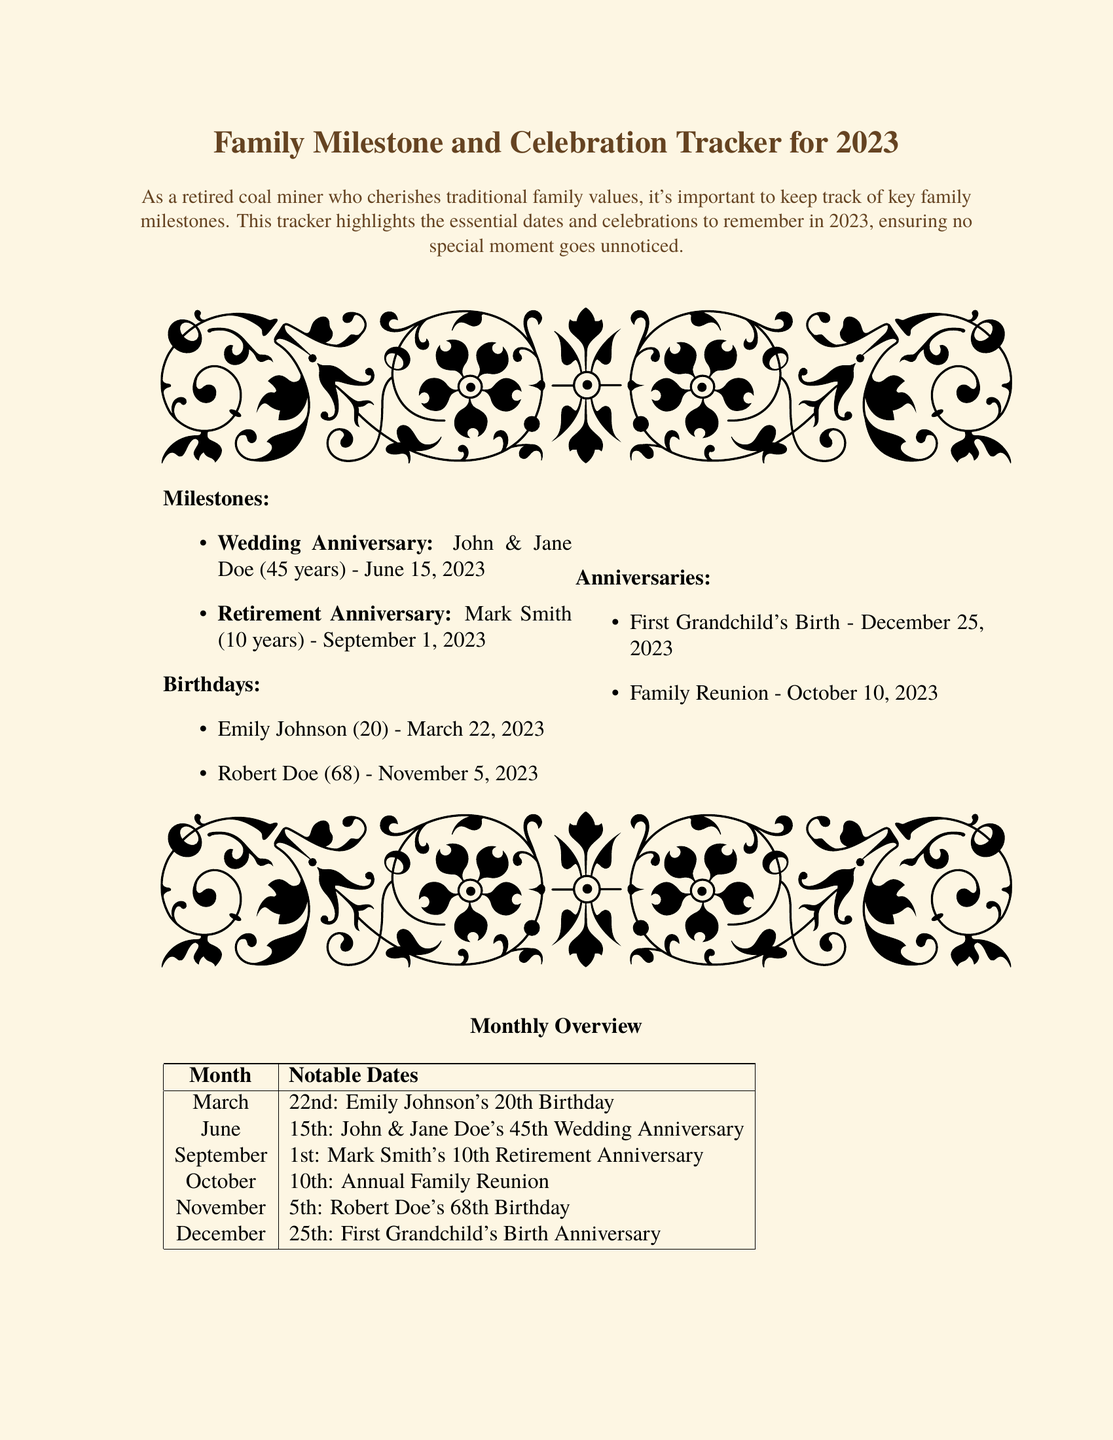What is the wedding anniversary of John and Jane Doe? The wedding anniversary date for John and Jane Doe is specifically mentioned in the milestones section of the document.
Answer: June 15, 2023 How long has Mark Smith been retired? The retirement anniversary is stated in the document, indicating how many years Mark Smith has been retired.
Answer: 10 years When is Emily Johnson's birthday? The document specifies the exact date of Emily Johnson's birthday under the birthdays section.
Answer: March 22, 2023 What significant family event is scheduled for October 10? The document highlights the notable event taking place on that date in the anniversaries section.
Answer: Family Reunion What is the birth date of Robert Doe? The date of Robert Doe's birthday is given explicitly in the document.
Answer: November 5, 2023 How many years is John and Jane Doe's wedding anniversary being celebrated? The document details the number of years being celebrated for John and Jane Doe's anniversary.
Answer: 45 years What is the main theme of the document? The document emphasizes the importance of family milestones and celebrations.
Answer: Family traditions What is the date of the first grandchild's birth? The document lists the first grandchild's birth date under the anniversaries section.
Answer: December 25, 2023 What color is the background of the document? The document's color scheme is defined, with the background described prominently.
Answer: Old paper 